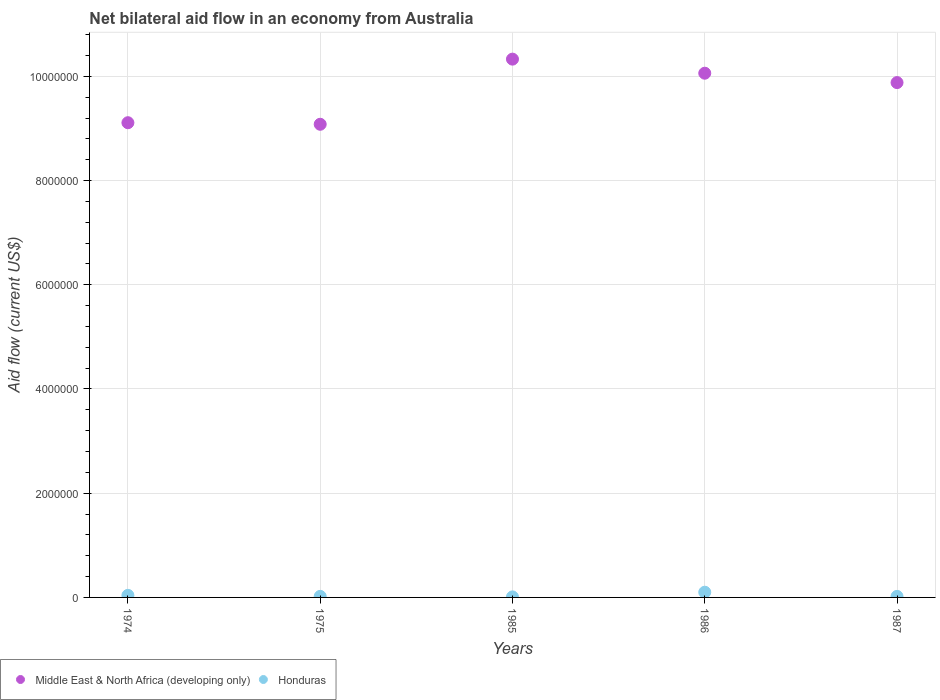How many different coloured dotlines are there?
Provide a short and direct response. 2. Is the number of dotlines equal to the number of legend labels?
Give a very brief answer. Yes. What is the net bilateral aid flow in Honduras in 1987?
Offer a very short reply. 2.00e+04. Across all years, what is the minimum net bilateral aid flow in Middle East & North Africa (developing only)?
Give a very brief answer. 9.08e+06. In which year was the net bilateral aid flow in Honduras maximum?
Your answer should be very brief. 1986. In which year was the net bilateral aid flow in Middle East & North Africa (developing only) minimum?
Give a very brief answer. 1975. What is the total net bilateral aid flow in Honduras in the graph?
Your answer should be compact. 1.90e+05. What is the difference between the net bilateral aid flow in Honduras in 1975 and that in 1987?
Keep it short and to the point. 0. What is the difference between the net bilateral aid flow in Middle East & North Africa (developing only) in 1986 and the net bilateral aid flow in Honduras in 1974?
Make the answer very short. 1.00e+07. What is the average net bilateral aid flow in Middle East & North Africa (developing only) per year?
Your answer should be very brief. 9.69e+06. In the year 1974, what is the difference between the net bilateral aid flow in Middle East & North Africa (developing only) and net bilateral aid flow in Honduras?
Give a very brief answer. 9.07e+06. Is the net bilateral aid flow in Middle East & North Africa (developing only) in 1985 less than that in 1986?
Ensure brevity in your answer.  No. What is the difference between the highest and the second highest net bilateral aid flow in Middle East & North Africa (developing only)?
Your answer should be very brief. 2.70e+05. In how many years, is the net bilateral aid flow in Middle East & North Africa (developing only) greater than the average net bilateral aid flow in Middle East & North Africa (developing only) taken over all years?
Make the answer very short. 3. Is the net bilateral aid flow in Middle East & North Africa (developing only) strictly greater than the net bilateral aid flow in Honduras over the years?
Your answer should be compact. Yes. How many dotlines are there?
Your response must be concise. 2. Are the values on the major ticks of Y-axis written in scientific E-notation?
Your answer should be very brief. No. Does the graph contain any zero values?
Your response must be concise. No. Does the graph contain grids?
Make the answer very short. Yes. Where does the legend appear in the graph?
Offer a terse response. Bottom left. What is the title of the graph?
Ensure brevity in your answer.  Net bilateral aid flow in an economy from Australia. What is the Aid flow (current US$) in Middle East & North Africa (developing only) in 1974?
Offer a terse response. 9.11e+06. What is the Aid flow (current US$) in Middle East & North Africa (developing only) in 1975?
Provide a short and direct response. 9.08e+06. What is the Aid flow (current US$) of Middle East & North Africa (developing only) in 1985?
Your response must be concise. 1.03e+07. What is the Aid flow (current US$) in Middle East & North Africa (developing only) in 1986?
Offer a very short reply. 1.01e+07. What is the Aid flow (current US$) in Middle East & North Africa (developing only) in 1987?
Give a very brief answer. 9.88e+06. What is the Aid flow (current US$) in Honduras in 1987?
Offer a terse response. 2.00e+04. Across all years, what is the maximum Aid flow (current US$) in Middle East & North Africa (developing only)?
Offer a terse response. 1.03e+07. Across all years, what is the maximum Aid flow (current US$) of Honduras?
Your answer should be compact. 1.00e+05. Across all years, what is the minimum Aid flow (current US$) of Middle East & North Africa (developing only)?
Give a very brief answer. 9.08e+06. What is the total Aid flow (current US$) of Middle East & North Africa (developing only) in the graph?
Your response must be concise. 4.85e+07. What is the difference between the Aid flow (current US$) in Middle East & North Africa (developing only) in 1974 and that in 1985?
Your answer should be compact. -1.22e+06. What is the difference between the Aid flow (current US$) in Honduras in 1974 and that in 1985?
Offer a very short reply. 3.00e+04. What is the difference between the Aid flow (current US$) of Middle East & North Africa (developing only) in 1974 and that in 1986?
Provide a succinct answer. -9.50e+05. What is the difference between the Aid flow (current US$) of Middle East & North Africa (developing only) in 1974 and that in 1987?
Offer a very short reply. -7.70e+05. What is the difference between the Aid flow (current US$) in Honduras in 1974 and that in 1987?
Make the answer very short. 2.00e+04. What is the difference between the Aid flow (current US$) of Middle East & North Africa (developing only) in 1975 and that in 1985?
Your answer should be compact. -1.25e+06. What is the difference between the Aid flow (current US$) in Honduras in 1975 and that in 1985?
Offer a terse response. 10000. What is the difference between the Aid flow (current US$) of Middle East & North Africa (developing only) in 1975 and that in 1986?
Provide a short and direct response. -9.80e+05. What is the difference between the Aid flow (current US$) of Honduras in 1975 and that in 1986?
Your answer should be compact. -8.00e+04. What is the difference between the Aid flow (current US$) of Middle East & North Africa (developing only) in 1975 and that in 1987?
Keep it short and to the point. -8.00e+05. What is the difference between the Aid flow (current US$) in Honduras in 1975 and that in 1987?
Your answer should be compact. 0. What is the difference between the Aid flow (current US$) in Honduras in 1985 and that in 1986?
Make the answer very short. -9.00e+04. What is the difference between the Aid flow (current US$) of Middle East & North Africa (developing only) in 1985 and that in 1987?
Offer a terse response. 4.50e+05. What is the difference between the Aid flow (current US$) of Honduras in 1986 and that in 1987?
Your answer should be compact. 8.00e+04. What is the difference between the Aid flow (current US$) in Middle East & North Africa (developing only) in 1974 and the Aid flow (current US$) in Honduras in 1975?
Ensure brevity in your answer.  9.09e+06. What is the difference between the Aid flow (current US$) in Middle East & North Africa (developing only) in 1974 and the Aid flow (current US$) in Honduras in 1985?
Give a very brief answer. 9.10e+06. What is the difference between the Aid flow (current US$) in Middle East & North Africa (developing only) in 1974 and the Aid flow (current US$) in Honduras in 1986?
Your answer should be very brief. 9.01e+06. What is the difference between the Aid flow (current US$) of Middle East & North Africa (developing only) in 1974 and the Aid flow (current US$) of Honduras in 1987?
Ensure brevity in your answer.  9.09e+06. What is the difference between the Aid flow (current US$) of Middle East & North Africa (developing only) in 1975 and the Aid flow (current US$) of Honduras in 1985?
Offer a very short reply. 9.07e+06. What is the difference between the Aid flow (current US$) in Middle East & North Africa (developing only) in 1975 and the Aid flow (current US$) in Honduras in 1986?
Keep it short and to the point. 8.98e+06. What is the difference between the Aid flow (current US$) of Middle East & North Africa (developing only) in 1975 and the Aid flow (current US$) of Honduras in 1987?
Give a very brief answer. 9.06e+06. What is the difference between the Aid flow (current US$) of Middle East & North Africa (developing only) in 1985 and the Aid flow (current US$) of Honduras in 1986?
Your answer should be very brief. 1.02e+07. What is the difference between the Aid flow (current US$) in Middle East & North Africa (developing only) in 1985 and the Aid flow (current US$) in Honduras in 1987?
Provide a short and direct response. 1.03e+07. What is the difference between the Aid flow (current US$) in Middle East & North Africa (developing only) in 1986 and the Aid flow (current US$) in Honduras in 1987?
Your answer should be compact. 1.00e+07. What is the average Aid flow (current US$) in Middle East & North Africa (developing only) per year?
Your response must be concise. 9.69e+06. What is the average Aid flow (current US$) of Honduras per year?
Give a very brief answer. 3.80e+04. In the year 1974, what is the difference between the Aid flow (current US$) in Middle East & North Africa (developing only) and Aid flow (current US$) in Honduras?
Your response must be concise. 9.07e+06. In the year 1975, what is the difference between the Aid flow (current US$) in Middle East & North Africa (developing only) and Aid flow (current US$) in Honduras?
Provide a short and direct response. 9.06e+06. In the year 1985, what is the difference between the Aid flow (current US$) in Middle East & North Africa (developing only) and Aid flow (current US$) in Honduras?
Your answer should be very brief. 1.03e+07. In the year 1986, what is the difference between the Aid flow (current US$) in Middle East & North Africa (developing only) and Aid flow (current US$) in Honduras?
Make the answer very short. 9.96e+06. In the year 1987, what is the difference between the Aid flow (current US$) in Middle East & North Africa (developing only) and Aid flow (current US$) in Honduras?
Offer a terse response. 9.86e+06. What is the ratio of the Aid flow (current US$) of Honduras in 1974 to that in 1975?
Your answer should be very brief. 2. What is the ratio of the Aid flow (current US$) of Middle East & North Africa (developing only) in 1974 to that in 1985?
Provide a short and direct response. 0.88. What is the ratio of the Aid flow (current US$) in Middle East & North Africa (developing only) in 1974 to that in 1986?
Ensure brevity in your answer.  0.91. What is the ratio of the Aid flow (current US$) in Middle East & North Africa (developing only) in 1974 to that in 1987?
Provide a succinct answer. 0.92. What is the ratio of the Aid flow (current US$) of Middle East & North Africa (developing only) in 1975 to that in 1985?
Keep it short and to the point. 0.88. What is the ratio of the Aid flow (current US$) in Honduras in 1975 to that in 1985?
Your answer should be compact. 2. What is the ratio of the Aid flow (current US$) of Middle East & North Africa (developing only) in 1975 to that in 1986?
Provide a short and direct response. 0.9. What is the ratio of the Aid flow (current US$) of Middle East & North Africa (developing only) in 1975 to that in 1987?
Your answer should be compact. 0.92. What is the ratio of the Aid flow (current US$) of Middle East & North Africa (developing only) in 1985 to that in 1986?
Offer a terse response. 1.03. What is the ratio of the Aid flow (current US$) in Middle East & North Africa (developing only) in 1985 to that in 1987?
Your response must be concise. 1.05. What is the ratio of the Aid flow (current US$) in Honduras in 1985 to that in 1987?
Provide a succinct answer. 0.5. What is the ratio of the Aid flow (current US$) of Middle East & North Africa (developing only) in 1986 to that in 1987?
Offer a very short reply. 1.02. What is the ratio of the Aid flow (current US$) in Honduras in 1986 to that in 1987?
Give a very brief answer. 5. What is the difference between the highest and the lowest Aid flow (current US$) in Middle East & North Africa (developing only)?
Provide a succinct answer. 1.25e+06. 